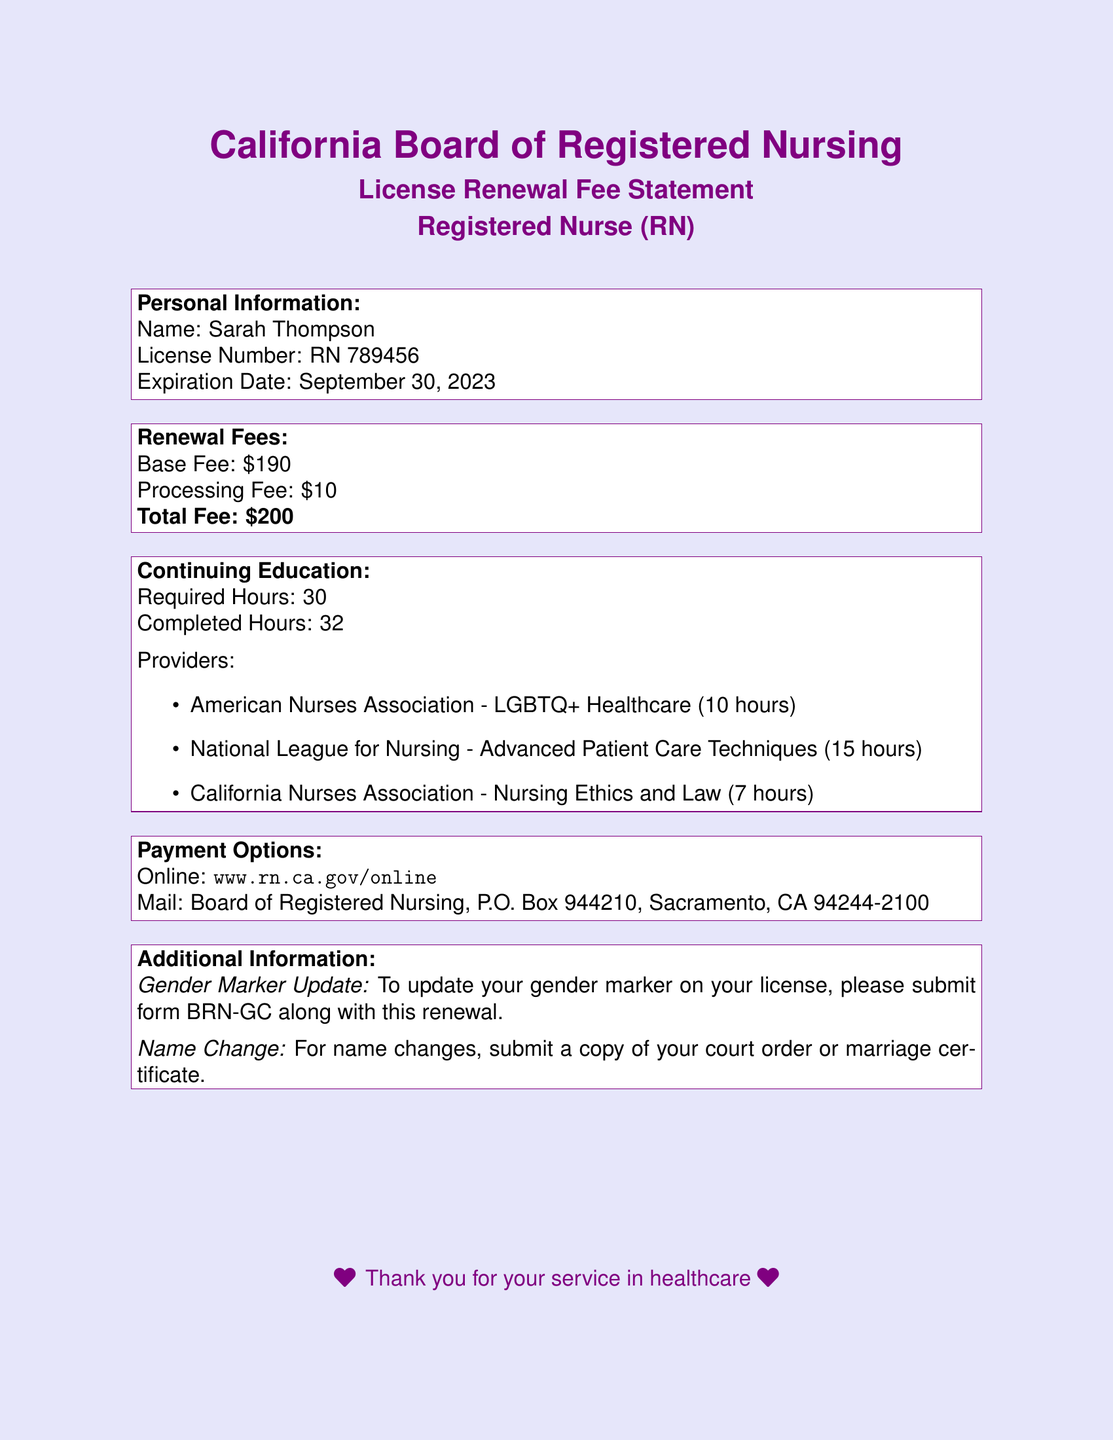What is the name of the registered nurse? The document lists the registered nurse's name as Sarah Thompson.
Answer: Sarah Thompson What is the license number? The license number provided in the document is specifically RN 789456.
Answer: RN 789456 When is the expiration date of the license? The document states that the expiration date of the license is September 30, 2023.
Answer: September 30, 2023 What is the total renewal fee? The total renewal fee is calculated as the base fee plus the processing fee, which amounts to $200.
Answer: $200 How many continuing education hours are required? According to the document, the required continuing education hours for renewal are 30.
Answer: 30 How many hours of continuing education has Sarah completed? The document indicates that Sarah has completed a total of 32 continuing education hours.
Answer: 32 What is one of the providers for continuing education? The document lists multiple providers, one of which is the American Nurses Association.
Answer: American Nurses Association What is the website for online payment? The document provides the website for online payment as www.rn.ca.gov/online.
Answer: www.rn.ca.gov/online What additional form must be submitted to update the gender marker? The document specifies that form BRN-GC must be submitted to update the gender marker.
Answer: BRN-GC 